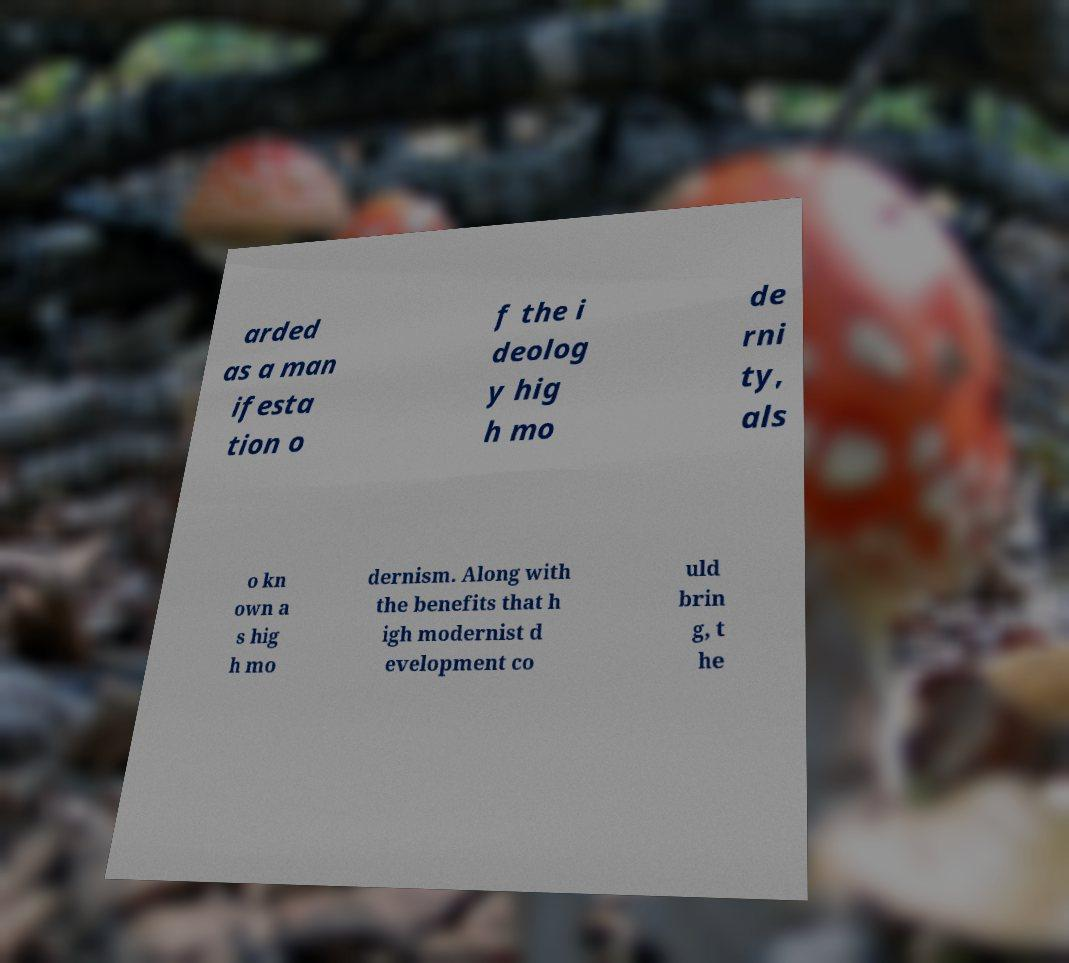Could you assist in decoding the text presented in this image and type it out clearly? arded as a man ifesta tion o f the i deolog y hig h mo de rni ty, als o kn own a s hig h mo dernism. Along with the benefits that h igh modernist d evelopment co uld brin g, t he 